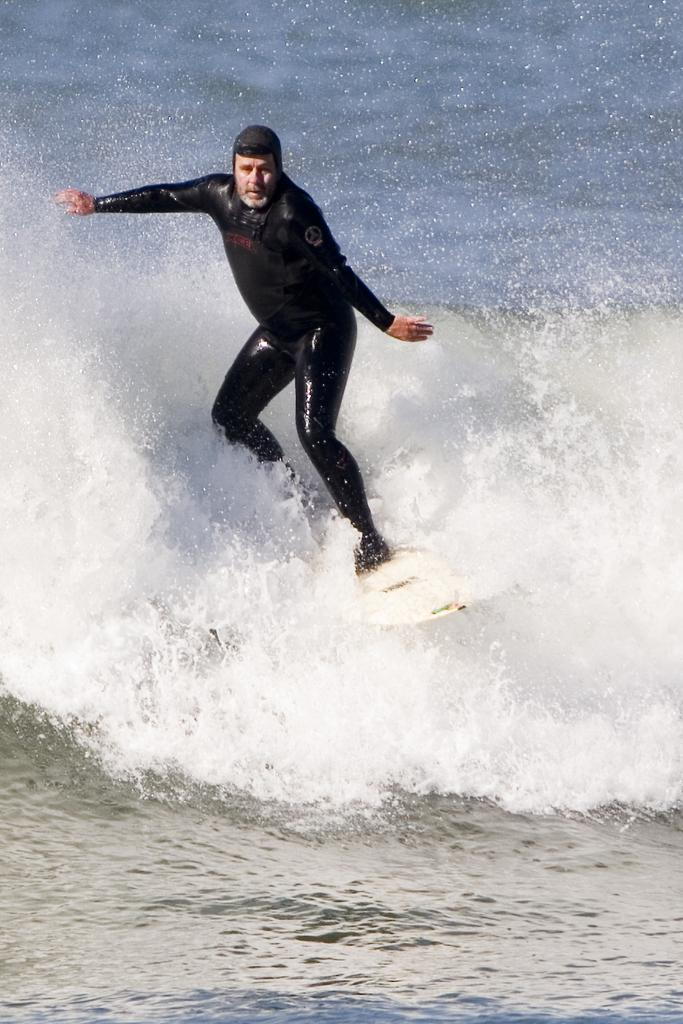Who is the main subject in the image? There is a person in the image. What is the person doing in the image? The person is surfing in the image. Where is the person surfing? The person is surfing in an ocean. What type of button can be seen on the tree in the image? There is no button or tree present in the image; it features a person surfing in an ocean. 